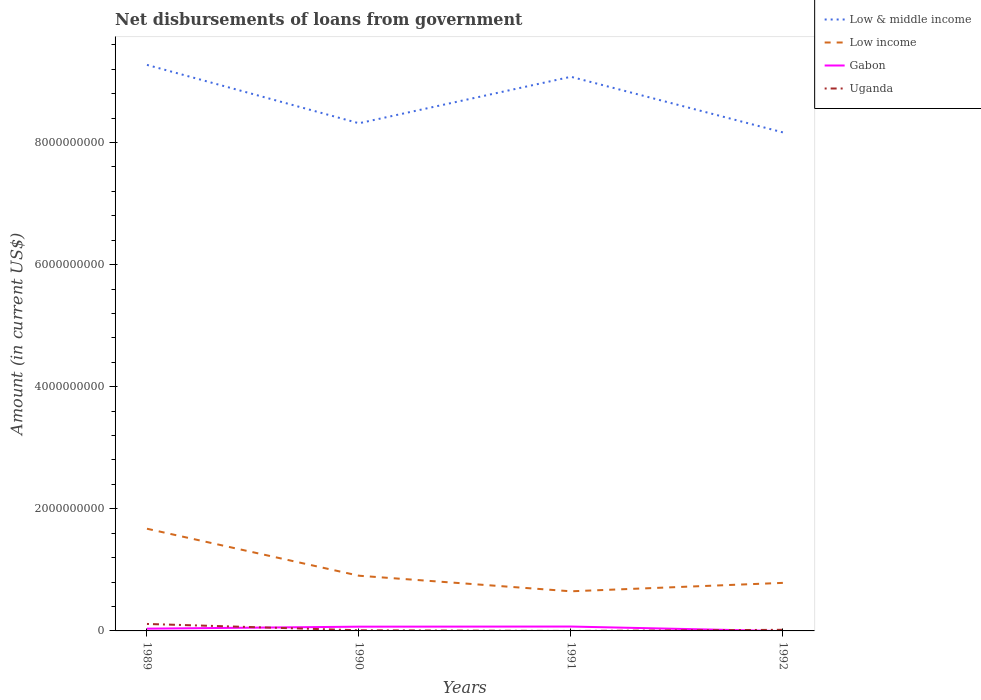Across all years, what is the maximum amount of loan disbursed from government in Low & middle income?
Your answer should be compact. 8.17e+09. What is the total amount of loan disbursed from government in Low income in the graph?
Your answer should be compact. 1.17e+08. What is the difference between the highest and the second highest amount of loan disbursed from government in Low & middle income?
Provide a succinct answer. 1.11e+09. What is the difference between the highest and the lowest amount of loan disbursed from government in Uganda?
Give a very brief answer. 1. What is the difference between two consecutive major ticks on the Y-axis?
Offer a terse response. 2.00e+09. Does the graph contain any zero values?
Provide a short and direct response. Yes. Does the graph contain grids?
Your answer should be compact. No. How many legend labels are there?
Make the answer very short. 4. What is the title of the graph?
Offer a terse response. Net disbursements of loans from government. Does "Gambia, The" appear as one of the legend labels in the graph?
Your response must be concise. No. What is the label or title of the Y-axis?
Offer a very short reply. Amount (in current US$). What is the Amount (in current US$) in Low & middle income in 1989?
Provide a succinct answer. 9.27e+09. What is the Amount (in current US$) in Low income in 1989?
Offer a very short reply. 1.67e+09. What is the Amount (in current US$) of Gabon in 1989?
Keep it short and to the point. 3.70e+07. What is the Amount (in current US$) of Uganda in 1989?
Your answer should be compact. 1.14e+08. What is the Amount (in current US$) in Low & middle income in 1990?
Offer a very short reply. 8.32e+09. What is the Amount (in current US$) in Low income in 1990?
Your answer should be very brief. 9.04e+08. What is the Amount (in current US$) in Gabon in 1990?
Your answer should be very brief. 6.95e+07. What is the Amount (in current US$) of Uganda in 1990?
Your response must be concise. 1.05e+07. What is the Amount (in current US$) in Low & middle income in 1991?
Offer a terse response. 9.08e+09. What is the Amount (in current US$) of Low income in 1991?
Make the answer very short. 6.49e+08. What is the Amount (in current US$) of Gabon in 1991?
Give a very brief answer. 7.17e+07. What is the Amount (in current US$) in Uganda in 1991?
Make the answer very short. 0. What is the Amount (in current US$) in Low & middle income in 1992?
Ensure brevity in your answer.  8.17e+09. What is the Amount (in current US$) in Low income in 1992?
Your answer should be compact. 7.87e+08. What is the Amount (in current US$) of Uganda in 1992?
Your answer should be very brief. 1.81e+07. Across all years, what is the maximum Amount (in current US$) of Low & middle income?
Make the answer very short. 9.27e+09. Across all years, what is the maximum Amount (in current US$) of Low income?
Keep it short and to the point. 1.67e+09. Across all years, what is the maximum Amount (in current US$) in Gabon?
Give a very brief answer. 7.17e+07. Across all years, what is the maximum Amount (in current US$) in Uganda?
Provide a short and direct response. 1.14e+08. Across all years, what is the minimum Amount (in current US$) in Low & middle income?
Your answer should be very brief. 8.17e+09. Across all years, what is the minimum Amount (in current US$) of Low income?
Provide a succinct answer. 6.49e+08. Across all years, what is the minimum Amount (in current US$) in Gabon?
Provide a short and direct response. 0. Across all years, what is the minimum Amount (in current US$) in Uganda?
Offer a terse response. 0. What is the total Amount (in current US$) of Low & middle income in the graph?
Ensure brevity in your answer.  3.48e+1. What is the total Amount (in current US$) in Low income in the graph?
Provide a succinct answer. 4.01e+09. What is the total Amount (in current US$) in Gabon in the graph?
Make the answer very short. 1.78e+08. What is the total Amount (in current US$) of Uganda in the graph?
Provide a succinct answer. 1.43e+08. What is the difference between the Amount (in current US$) in Low & middle income in 1989 and that in 1990?
Your response must be concise. 9.56e+08. What is the difference between the Amount (in current US$) in Low income in 1989 and that in 1990?
Offer a terse response. 7.70e+08. What is the difference between the Amount (in current US$) in Gabon in 1989 and that in 1990?
Your response must be concise. -3.25e+07. What is the difference between the Amount (in current US$) of Uganda in 1989 and that in 1990?
Ensure brevity in your answer.  1.04e+08. What is the difference between the Amount (in current US$) of Low & middle income in 1989 and that in 1991?
Provide a short and direct response. 1.95e+08. What is the difference between the Amount (in current US$) of Low income in 1989 and that in 1991?
Keep it short and to the point. 1.02e+09. What is the difference between the Amount (in current US$) of Gabon in 1989 and that in 1991?
Your answer should be compact. -3.46e+07. What is the difference between the Amount (in current US$) of Low & middle income in 1989 and that in 1992?
Provide a short and direct response. 1.11e+09. What is the difference between the Amount (in current US$) of Low income in 1989 and that in 1992?
Your response must be concise. 8.87e+08. What is the difference between the Amount (in current US$) in Uganda in 1989 and that in 1992?
Make the answer very short. 9.60e+07. What is the difference between the Amount (in current US$) in Low & middle income in 1990 and that in 1991?
Your response must be concise. -7.61e+08. What is the difference between the Amount (in current US$) of Low income in 1990 and that in 1991?
Provide a short and direct response. 2.55e+08. What is the difference between the Amount (in current US$) of Gabon in 1990 and that in 1991?
Provide a short and direct response. -2.14e+06. What is the difference between the Amount (in current US$) in Low & middle income in 1990 and that in 1992?
Offer a very short reply. 1.49e+08. What is the difference between the Amount (in current US$) of Low income in 1990 and that in 1992?
Offer a very short reply. 1.17e+08. What is the difference between the Amount (in current US$) in Uganda in 1990 and that in 1992?
Your answer should be very brief. -7.61e+06. What is the difference between the Amount (in current US$) of Low & middle income in 1991 and that in 1992?
Your answer should be very brief. 9.11e+08. What is the difference between the Amount (in current US$) of Low income in 1991 and that in 1992?
Provide a short and direct response. -1.38e+08. What is the difference between the Amount (in current US$) in Low & middle income in 1989 and the Amount (in current US$) in Low income in 1990?
Keep it short and to the point. 8.37e+09. What is the difference between the Amount (in current US$) of Low & middle income in 1989 and the Amount (in current US$) of Gabon in 1990?
Provide a short and direct response. 9.20e+09. What is the difference between the Amount (in current US$) in Low & middle income in 1989 and the Amount (in current US$) in Uganda in 1990?
Give a very brief answer. 9.26e+09. What is the difference between the Amount (in current US$) of Low income in 1989 and the Amount (in current US$) of Gabon in 1990?
Keep it short and to the point. 1.60e+09. What is the difference between the Amount (in current US$) in Low income in 1989 and the Amount (in current US$) in Uganda in 1990?
Your answer should be very brief. 1.66e+09. What is the difference between the Amount (in current US$) in Gabon in 1989 and the Amount (in current US$) in Uganda in 1990?
Your response must be concise. 2.65e+07. What is the difference between the Amount (in current US$) of Low & middle income in 1989 and the Amount (in current US$) of Low income in 1991?
Your response must be concise. 8.62e+09. What is the difference between the Amount (in current US$) in Low & middle income in 1989 and the Amount (in current US$) in Gabon in 1991?
Your response must be concise. 9.20e+09. What is the difference between the Amount (in current US$) in Low income in 1989 and the Amount (in current US$) in Gabon in 1991?
Ensure brevity in your answer.  1.60e+09. What is the difference between the Amount (in current US$) in Low & middle income in 1989 and the Amount (in current US$) in Low income in 1992?
Make the answer very short. 8.48e+09. What is the difference between the Amount (in current US$) of Low & middle income in 1989 and the Amount (in current US$) of Uganda in 1992?
Keep it short and to the point. 9.25e+09. What is the difference between the Amount (in current US$) of Low income in 1989 and the Amount (in current US$) of Uganda in 1992?
Make the answer very short. 1.66e+09. What is the difference between the Amount (in current US$) in Gabon in 1989 and the Amount (in current US$) in Uganda in 1992?
Offer a very short reply. 1.89e+07. What is the difference between the Amount (in current US$) in Low & middle income in 1990 and the Amount (in current US$) in Low income in 1991?
Ensure brevity in your answer.  7.67e+09. What is the difference between the Amount (in current US$) in Low & middle income in 1990 and the Amount (in current US$) in Gabon in 1991?
Your answer should be very brief. 8.24e+09. What is the difference between the Amount (in current US$) of Low income in 1990 and the Amount (in current US$) of Gabon in 1991?
Make the answer very short. 8.33e+08. What is the difference between the Amount (in current US$) in Low & middle income in 1990 and the Amount (in current US$) in Low income in 1992?
Offer a terse response. 7.53e+09. What is the difference between the Amount (in current US$) in Low & middle income in 1990 and the Amount (in current US$) in Uganda in 1992?
Your response must be concise. 8.30e+09. What is the difference between the Amount (in current US$) in Low income in 1990 and the Amount (in current US$) in Uganda in 1992?
Your response must be concise. 8.86e+08. What is the difference between the Amount (in current US$) in Gabon in 1990 and the Amount (in current US$) in Uganda in 1992?
Your response must be concise. 5.14e+07. What is the difference between the Amount (in current US$) in Low & middle income in 1991 and the Amount (in current US$) in Low income in 1992?
Provide a succinct answer. 8.29e+09. What is the difference between the Amount (in current US$) in Low & middle income in 1991 and the Amount (in current US$) in Uganda in 1992?
Offer a terse response. 9.06e+09. What is the difference between the Amount (in current US$) in Low income in 1991 and the Amount (in current US$) in Uganda in 1992?
Keep it short and to the point. 6.31e+08. What is the difference between the Amount (in current US$) in Gabon in 1991 and the Amount (in current US$) in Uganda in 1992?
Offer a terse response. 5.35e+07. What is the average Amount (in current US$) in Low & middle income per year?
Make the answer very short. 8.71e+09. What is the average Amount (in current US$) of Low income per year?
Make the answer very short. 1.00e+09. What is the average Amount (in current US$) in Gabon per year?
Offer a terse response. 4.46e+07. What is the average Amount (in current US$) of Uganda per year?
Your response must be concise. 3.57e+07. In the year 1989, what is the difference between the Amount (in current US$) of Low & middle income and Amount (in current US$) of Low income?
Your answer should be very brief. 7.60e+09. In the year 1989, what is the difference between the Amount (in current US$) of Low & middle income and Amount (in current US$) of Gabon?
Your answer should be compact. 9.23e+09. In the year 1989, what is the difference between the Amount (in current US$) of Low & middle income and Amount (in current US$) of Uganda?
Offer a terse response. 9.16e+09. In the year 1989, what is the difference between the Amount (in current US$) of Low income and Amount (in current US$) of Gabon?
Offer a very short reply. 1.64e+09. In the year 1989, what is the difference between the Amount (in current US$) in Low income and Amount (in current US$) in Uganda?
Provide a short and direct response. 1.56e+09. In the year 1989, what is the difference between the Amount (in current US$) in Gabon and Amount (in current US$) in Uganda?
Provide a short and direct response. -7.70e+07. In the year 1990, what is the difference between the Amount (in current US$) of Low & middle income and Amount (in current US$) of Low income?
Ensure brevity in your answer.  7.41e+09. In the year 1990, what is the difference between the Amount (in current US$) in Low & middle income and Amount (in current US$) in Gabon?
Give a very brief answer. 8.25e+09. In the year 1990, what is the difference between the Amount (in current US$) of Low & middle income and Amount (in current US$) of Uganda?
Provide a succinct answer. 8.30e+09. In the year 1990, what is the difference between the Amount (in current US$) of Low income and Amount (in current US$) of Gabon?
Make the answer very short. 8.35e+08. In the year 1990, what is the difference between the Amount (in current US$) in Low income and Amount (in current US$) in Uganda?
Ensure brevity in your answer.  8.94e+08. In the year 1990, what is the difference between the Amount (in current US$) in Gabon and Amount (in current US$) in Uganda?
Ensure brevity in your answer.  5.90e+07. In the year 1991, what is the difference between the Amount (in current US$) of Low & middle income and Amount (in current US$) of Low income?
Keep it short and to the point. 8.43e+09. In the year 1991, what is the difference between the Amount (in current US$) in Low & middle income and Amount (in current US$) in Gabon?
Your response must be concise. 9.01e+09. In the year 1991, what is the difference between the Amount (in current US$) in Low income and Amount (in current US$) in Gabon?
Your answer should be compact. 5.77e+08. In the year 1992, what is the difference between the Amount (in current US$) of Low & middle income and Amount (in current US$) of Low income?
Ensure brevity in your answer.  7.38e+09. In the year 1992, what is the difference between the Amount (in current US$) in Low & middle income and Amount (in current US$) in Uganda?
Keep it short and to the point. 8.15e+09. In the year 1992, what is the difference between the Amount (in current US$) in Low income and Amount (in current US$) in Uganda?
Your answer should be very brief. 7.69e+08. What is the ratio of the Amount (in current US$) in Low & middle income in 1989 to that in 1990?
Give a very brief answer. 1.11. What is the ratio of the Amount (in current US$) in Low income in 1989 to that in 1990?
Offer a very short reply. 1.85. What is the ratio of the Amount (in current US$) in Gabon in 1989 to that in 1990?
Provide a short and direct response. 0.53. What is the ratio of the Amount (in current US$) of Uganda in 1989 to that in 1990?
Offer a very short reply. 10.86. What is the ratio of the Amount (in current US$) in Low & middle income in 1989 to that in 1991?
Your response must be concise. 1.02. What is the ratio of the Amount (in current US$) in Low income in 1989 to that in 1991?
Your response must be concise. 2.58. What is the ratio of the Amount (in current US$) in Gabon in 1989 to that in 1991?
Provide a short and direct response. 0.52. What is the ratio of the Amount (in current US$) in Low & middle income in 1989 to that in 1992?
Your answer should be compact. 1.14. What is the ratio of the Amount (in current US$) in Low income in 1989 to that in 1992?
Provide a succinct answer. 2.13. What is the ratio of the Amount (in current US$) in Uganda in 1989 to that in 1992?
Keep it short and to the point. 6.3. What is the ratio of the Amount (in current US$) in Low & middle income in 1990 to that in 1991?
Offer a very short reply. 0.92. What is the ratio of the Amount (in current US$) of Low income in 1990 to that in 1991?
Make the answer very short. 1.39. What is the ratio of the Amount (in current US$) of Gabon in 1990 to that in 1991?
Your answer should be compact. 0.97. What is the ratio of the Amount (in current US$) of Low & middle income in 1990 to that in 1992?
Offer a terse response. 1.02. What is the ratio of the Amount (in current US$) of Low income in 1990 to that in 1992?
Offer a very short reply. 1.15. What is the ratio of the Amount (in current US$) of Uganda in 1990 to that in 1992?
Offer a terse response. 0.58. What is the ratio of the Amount (in current US$) of Low & middle income in 1991 to that in 1992?
Keep it short and to the point. 1.11. What is the ratio of the Amount (in current US$) in Low income in 1991 to that in 1992?
Offer a terse response. 0.82. What is the difference between the highest and the second highest Amount (in current US$) in Low & middle income?
Provide a succinct answer. 1.95e+08. What is the difference between the highest and the second highest Amount (in current US$) of Low income?
Give a very brief answer. 7.70e+08. What is the difference between the highest and the second highest Amount (in current US$) in Gabon?
Your answer should be compact. 2.14e+06. What is the difference between the highest and the second highest Amount (in current US$) of Uganda?
Your response must be concise. 9.60e+07. What is the difference between the highest and the lowest Amount (in current US$) in Low & middle income?
Provide a succinct answer. 1.11e+09. What is the difference between the highest and the lowest Amount (in current US$) in Low income?
Offer a very short reply. 1.02e+09. What is the difference between the highest and the lowest Amount (in current US$) in Gabon?
Provide a short and direct response. 7.17e+07. What is the difference between the highest and the lowest Amount (in current US$) of Uganda?
Give a very brief answer. 1.14e+08. 